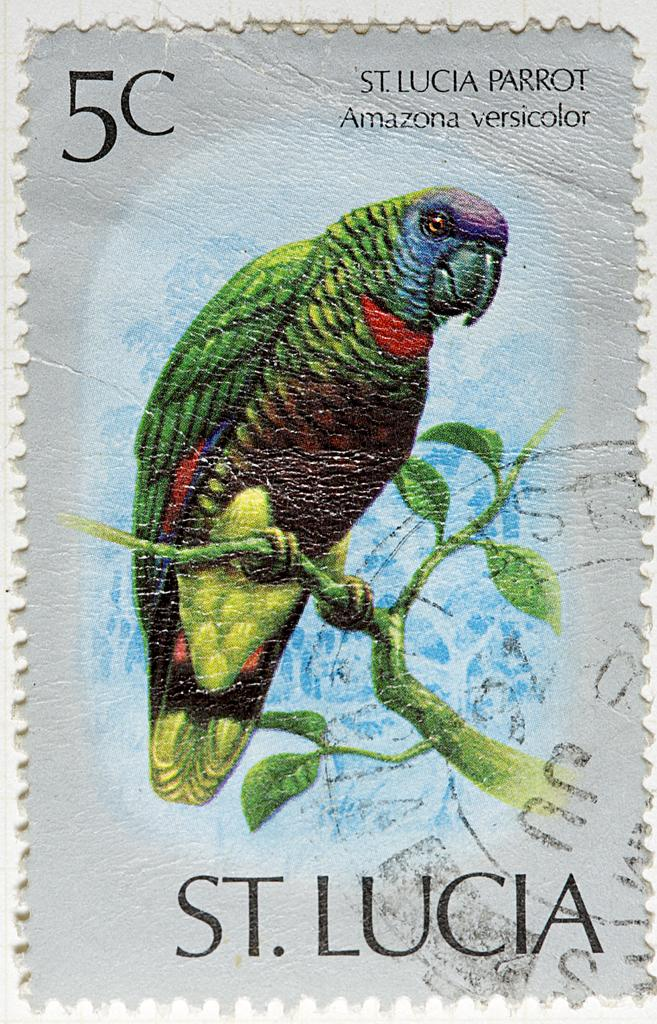What type of visual is the image? The image is a poster. What animal is depicted in the poster? There is a parrot depicted in the image. Where is the parrot positioned in the image? The parrot is standing on the branch of a tree. Is there any text present on the image? Yes, there is text on the image. What type of liquid can be seen dripping from the parrot's beak in the image? There is no liquid dripping from the parrot's beak in the image. How many horses are visible in the image? There are no horses present in the image; it features a parrot on a tree branch. 